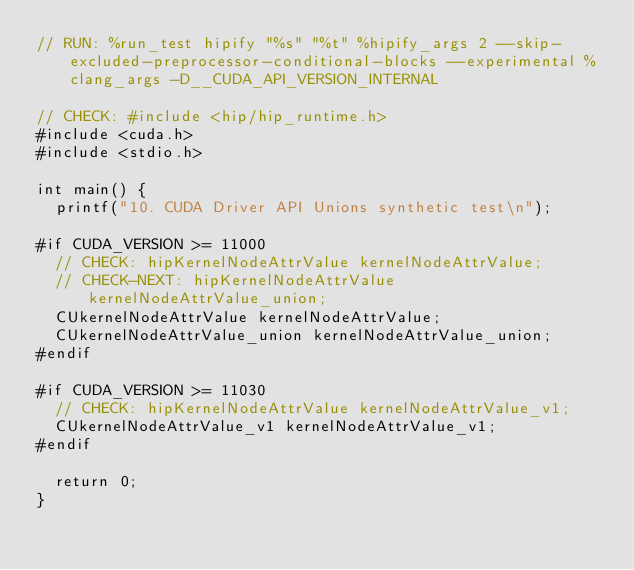Convert code to text. <code><loc_0><loc_0><loc_500><loc_500><_Cuda_>// RUN: %run_test hipify "%s" "%t" %hipify_args 2 --skip-excluded-preprocessor-conditional-blocks --experimental %clang_args -D__CUDA_API_VERSION_INTERNAL

// CHECK: #include <hip/hip_runtime.h>
#include <cuda.h>
#include <stdio.h>

int main() {
  printf("10. CUDA Driver API Unions synthetic test\n");

#if CUDA_VERSION >= 11000
  // CHECK: hipKernelNodeAttrValue kernelNodeAttrValue;
  // CHECK-NEXT: hipKernelNodeAttrValue kernelNodeAttrValue_union;
  CUkernelNodeAttrValue kernelNodeAttrValue;
  CUkernelNodeAttrValue_union kernelNodeAttrValue_union;
#endif

#if CUDA_VERSION >= 11030
  // CHECK: hipKernelNodeAttrValue kernelNodeAttrValue_v1;
  CUkernelNodeAttrValue_v1 kernelNodeAttrValue_v1;
#endif

  return 0;
}
</code> 